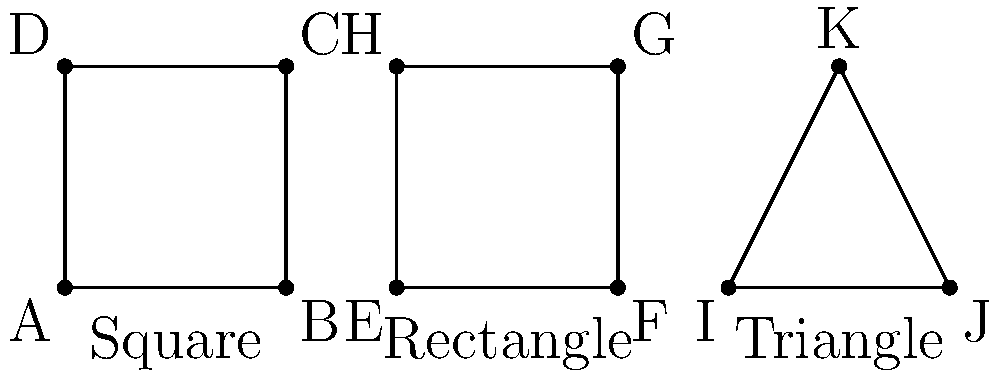As a package store owner, you're considering the symmetry of different bottle shapes for efficient shelf organization. Given the three basic shapes shown (square, rectangle, and triangle), which shape has the highest degree of rotational symmetry, and how many distinct rotations (including the identity rotation) does it have that leave the shape unchanged? To determine the shape with the highest degree of rotational symmetry and its number of distinct rotations, let's analyze each shape:

1. Square:
   - The square has 4-fold rotational symmetry.
   - It can be rotated 0°, 90°, 180°, and 270° to appear unchanged.
   - Number of distinct rotations: 4

2. Rectangle:
   - The rectangle has 2-fold rotational symmetry.
   - It can be rotated 0° and 180° to appear unchanged.
   - Number of distinct rotations: 2

3. Triangle:
   - This is an isosceles triangle, which has 1-fold rotational symmetry.
   - It can only be rotated 0° (identity rotation) to appear unchanged.
   - Number of distinct rotations: 1

Comparing the three shapes, the square has the highest degree of rotational symmetry with 4 distinct rotations.

For shelf organization, this means that square bottles can be placed in four different orientations without changing their appearance or how they fit on the shelf, offering the most flexibility in arrangement.
Answer: Square, 4 rotations 